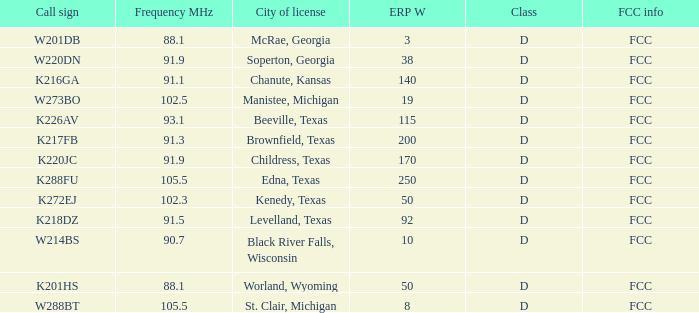What is the call sign for a city of license in brownfield, texas? K217FB. Parse the table in full. {'header': ['Call sign', 'Frequency MHz', 'City of license', 'ERP W', 'Class', 'FCC info'], 'rows': [['W201DB', '88.1', 'McRae, Georgia', '3', 'D', 'FCC'], ['W220DN', '91.9', 'Soperton, Georgia', '38', 'D', 'FCC'], ['K216GA', '91.1', 'Chanute, Kansas', '140', 'D', 'FCC'], ['W273BO', '102.5', 'Manistee, Michigan', '19', 'D', 'FCC'], ['K226AV', '93.1', 'Beeville, Texas', '115', 'D', 'FCC'], ['K217FB', '91.3', 'Brownfield, Texas', '200', 'D', 'FCC'], ['K220JC', '91.9', 'Childress, Texas', '170', 'D', 'FCC'], ['K288FU', '105.5', 'Edna, Texas', '250', 'D', 'FCC'], ['K272EJ', '102.3', 'Kenedy, Texas', '50', 'D', 'FCC'], ['K218DZ', '91.5', 'Levelland, Texas', '92', 'D', 'FCC'], ['W214BS', '90.7', 'Black River Falls, Wisconsin', '10', 'D', 'FCC'], ['K201HS', '88.1', 'Worland, Wyoming', '50', 'D', 'FCC'], ['W288BT', '105.5', 'St. Clair, Michigan', '8', 'D', 'FCC']]} 